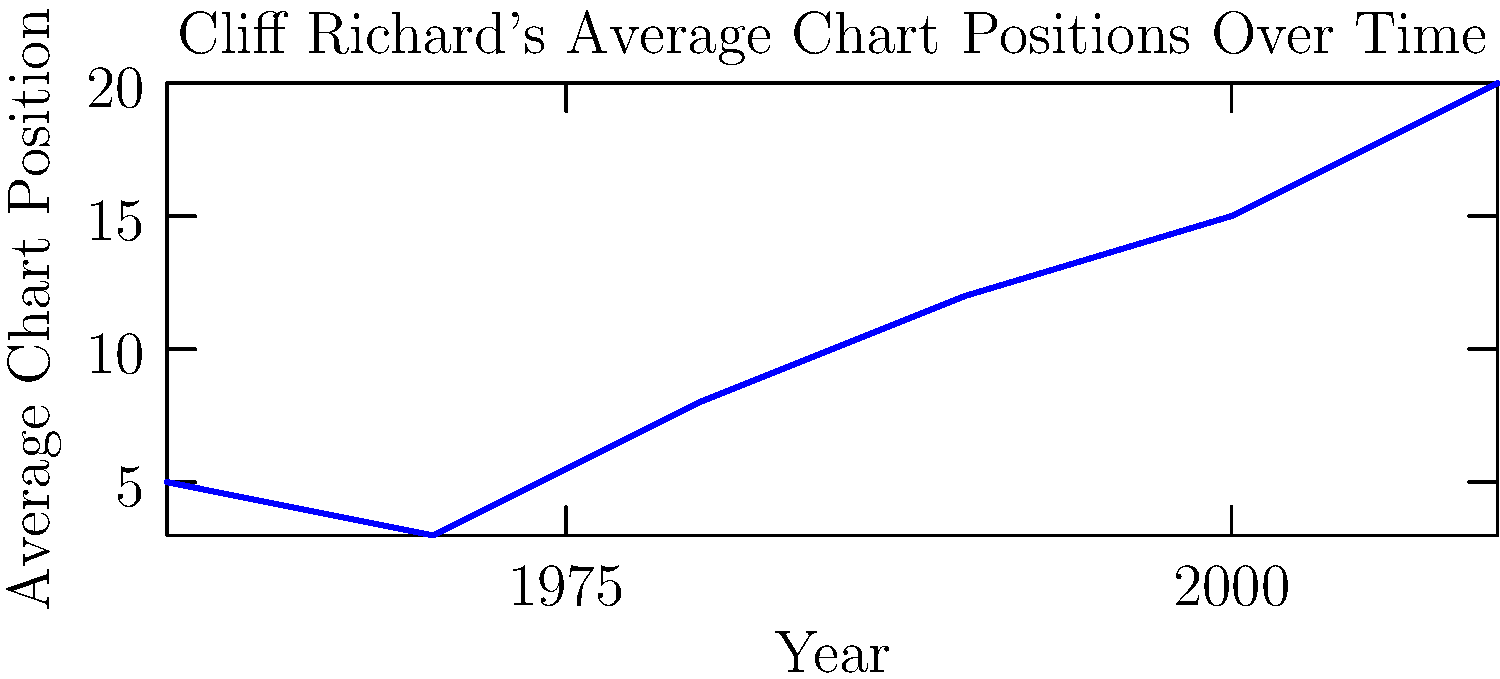Based on the graph showing Cliff Richard's average chart positions over time, what is the probability that a randomly selected Cliff Richard song from the 1970s would chart higher than position 10? To solve this problem, we need to follow these steps:

1. Identify the average chart position for Cliff Richard's songs in the 1970s.
From the graph, we can see that in 1970, the average position was 3.

2. Assume a normal distribution around this average.
Without more specific information, we'll assume the chart positions are normally distributed around the mean.

3. Use the empirical rule (68-95-99.7 rule) to estimate the spread.
Let's assume that 95% of the songs fall within 2 standard deviations of the mean.

4. Calculate the standard deviation.
If position 10 is approximately 2 standard deviations above the mean:
$10 - 3 = 2\sigma$
$\sigma = \frac{10-3}{2} = 3.5$

5. Calculate the z-score for position 10.
$z = \frac{x - \mu}{\sigma} = \frac{10 - 3}{3.5} \approx 2$

6. Use a z-table or normal distribution calculator to find the probability.
The probability of a z-score less than 2 is approximately 0.9772.

7. Calculate the probability of charting higher than position 10.
This is the complement of the probability we just calculated:
$1 - 0.9772 = 0.0228$

Therefore, the probability of a randomly selected Cliff Richard song from the 1970s charting higher than position 10 is approximately 0.0228 or 2.28%.
Answer: $0.0228$ or $2.28\%$ 